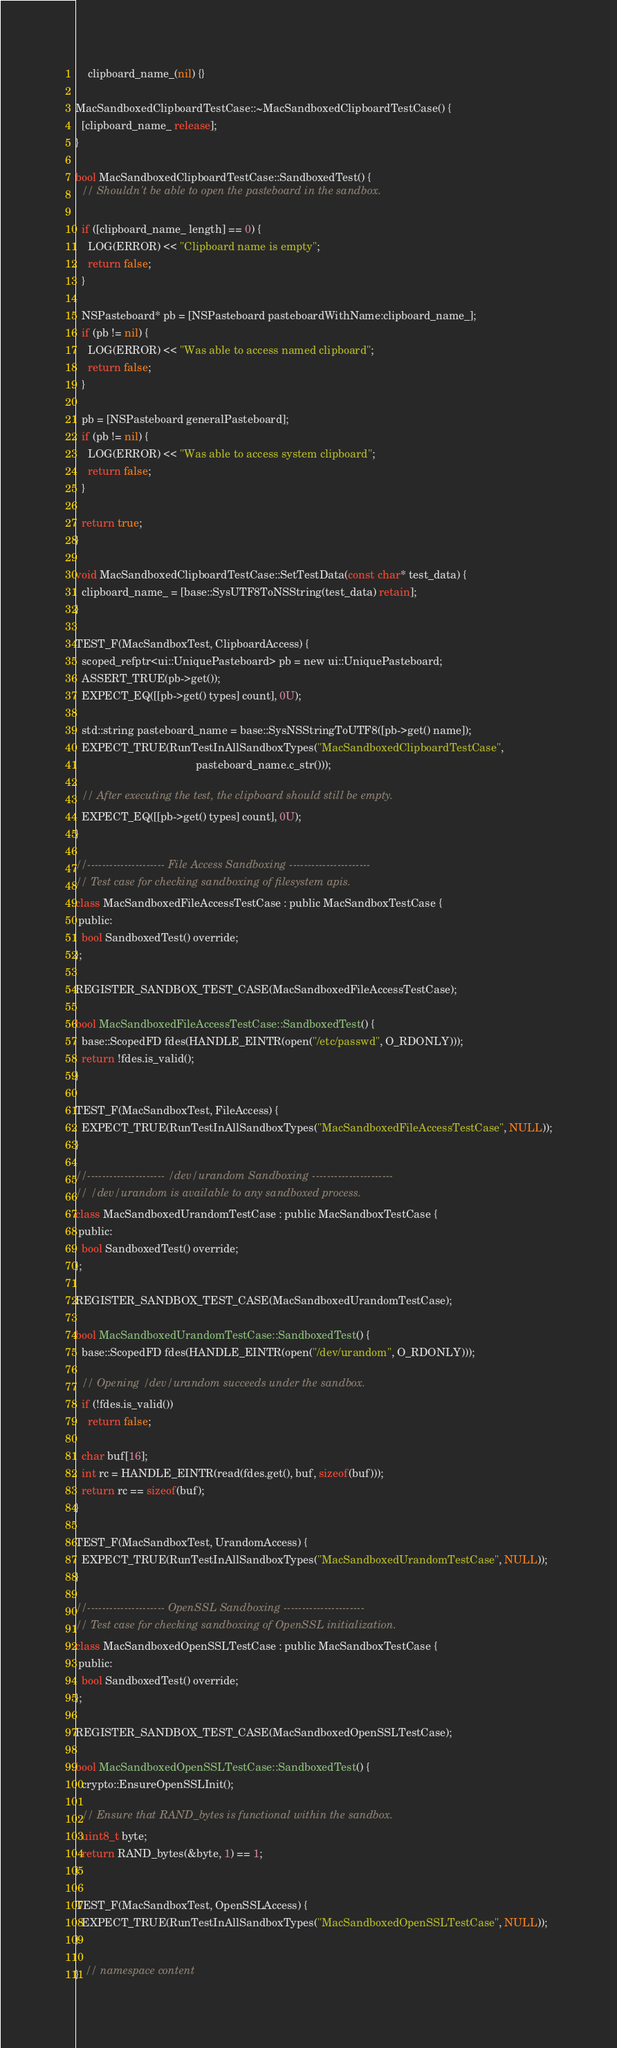<code> <loc_0><loc_0><loc_500><loc_500><_ObjectiveC_>    clipboard_name_(nil) {}

MacSandboxedClipboardTestCase::~MacSandboxedClipboardTestCase() {
  [clipboard_name_ release];
}

bool MacSandboxedClipboardTestCase::SandboxedTest() {
  // Shouldn't be able to open the pasteboard in the sandbox.

  if ([clipboard_name_ length] == 0) {
    LOG(ERROR) << "Clipboard name is empty";
    return false;
  }

  NSPasteboard* pb = [NSPasteboard pasteboardWithName:clipboard_name_];
  if (pb != nil) {
    LOG(ERROR) << "Was able to access named clipboard";
    return false;
  }

  pb = [NSPasteboard generalPasteboard];
  if (pb != nil) {
    LOG(ERROR) << "Was able to access system clipboard";
    return false;
  }

  return true;
}

void MacSandboxedClipboardTestCase::SetTestData(const char* test_data) {
  clipboard_name_ = [base::SysUTF8ToNSString(test_data) retain];
}

TEST_F(MacSandboxTest, ClipboardAccess) {
  scoped_refptr<ui::UniquePasteboard> pb = new ui::UniquePasteboard;
  ASSERT_TRUE(pb->get());
  EXPECT_EQ([[pb->get() types] count], 0U);

  std::string pasteboard_name = base::SysNSStringToUTF8([pb->get() name]);
  EXPECT_TRUE(RunTestInAllSandboxTypes("MacSandboxedClipboardTestCase",
                                       pasteboard_name.c_str()));

  // After executing the test, the clipboard should still be empty.
  EXPECT_EQ([[pb->get() types] count], 0U);
}

//--------------------- File Access Sandboxing ----------------------
// Test case for checking sandboxing of filesystem apis.
class MacSandboxedFileAccessTestCase : public MacSandboxTestCase {
 public:
  bool SandboxedTest() override;
};

REGISTER_SANDBOX_TEST_CASE(MacSandboxedFileAccessTestCase);

bool MacSandboxedFileAccessTestCase::SandboxedTest() {
  base::ScopedFD fdes(HANDLE_EINTR(open("/etc/passwd", O_RDONLY)));
  return !fdes.is_valid();
}

TEST_F(MacSandboxTest, FileAccess) {
  EXPECT_TRUE(RunTestInAllSandboxTypes("MacSandboxedFileAccessTestCase", NULL));
}

//--------------------- /dev/urandom Sandboxing ----------------------
// /dev/urandom is available to any sandboxed process.
class MacSandboxedUrandomTestCase : public MacSandboxTestCase {
 public:
  bool SandboxedTest() override;
};

REGISTER_SANDBOX_TEST_CASE(MacSandboxedUrandomTestCase);

bool MacSandboxedUrandomTestCase::SandboxedTest() {
  base::ScopedFD fdes(HANDLE_EINTR(open("/dev/urandom", O_RDONLY)));

  // Opening /dev/urandom succeeds under the sandbox.
  if (!fdes.is_valid())
    return false;

  char buf[16];
  int rc = HANDLE_EINTR(read(fdes.get(), buf, sizeof(buf)));
  return rc == sizeof(buf);
}

TEST_F(MacSandboxTest, UrandomAccess) {
  EXPECT_TRUE(RunTestInAllSandboxTypes("MacSandboxedUrandomTestCase", NULL));
}

//--------------------- OpenSSL Sandboxing ----------------------
// Test case for checking sandboxing of OpenSSL initialization.
class MacSandboxedOpenSSLTestCase : public MacSandboxTestCase {
 public:
  bool SandboxedTest() override;
};

REGISTER_SANDBOX_TEST_CASE(MacSandboxedOpenSSLTestCase);

bool MacSandboxedOpenSSLTestCase::SandboxedTest() {
  crypto::EnsureOpenSSLInit();

  // Ensure that RAND_bytes is functional within the sandbox.
  uint8_t byte;
  return RAND_bytes(&byte, 1) == 1;
}

TEST_F(MacSandboxTest, OpenSSLAccess) {
  EXPECT_TRUE(RunTestInAllSandboxTypes("MacSandboxedOpenSSLTestCase", NULL));
}

}  // namespace content
</code> 